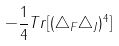<formula> <loc_0><loc_0><loc_500><loc_500>- \frac { 1 } { 4 } T r [ ( { \triangle _ { F } \triangle _ { J } } ) ^ { 4 } ]</formula> 